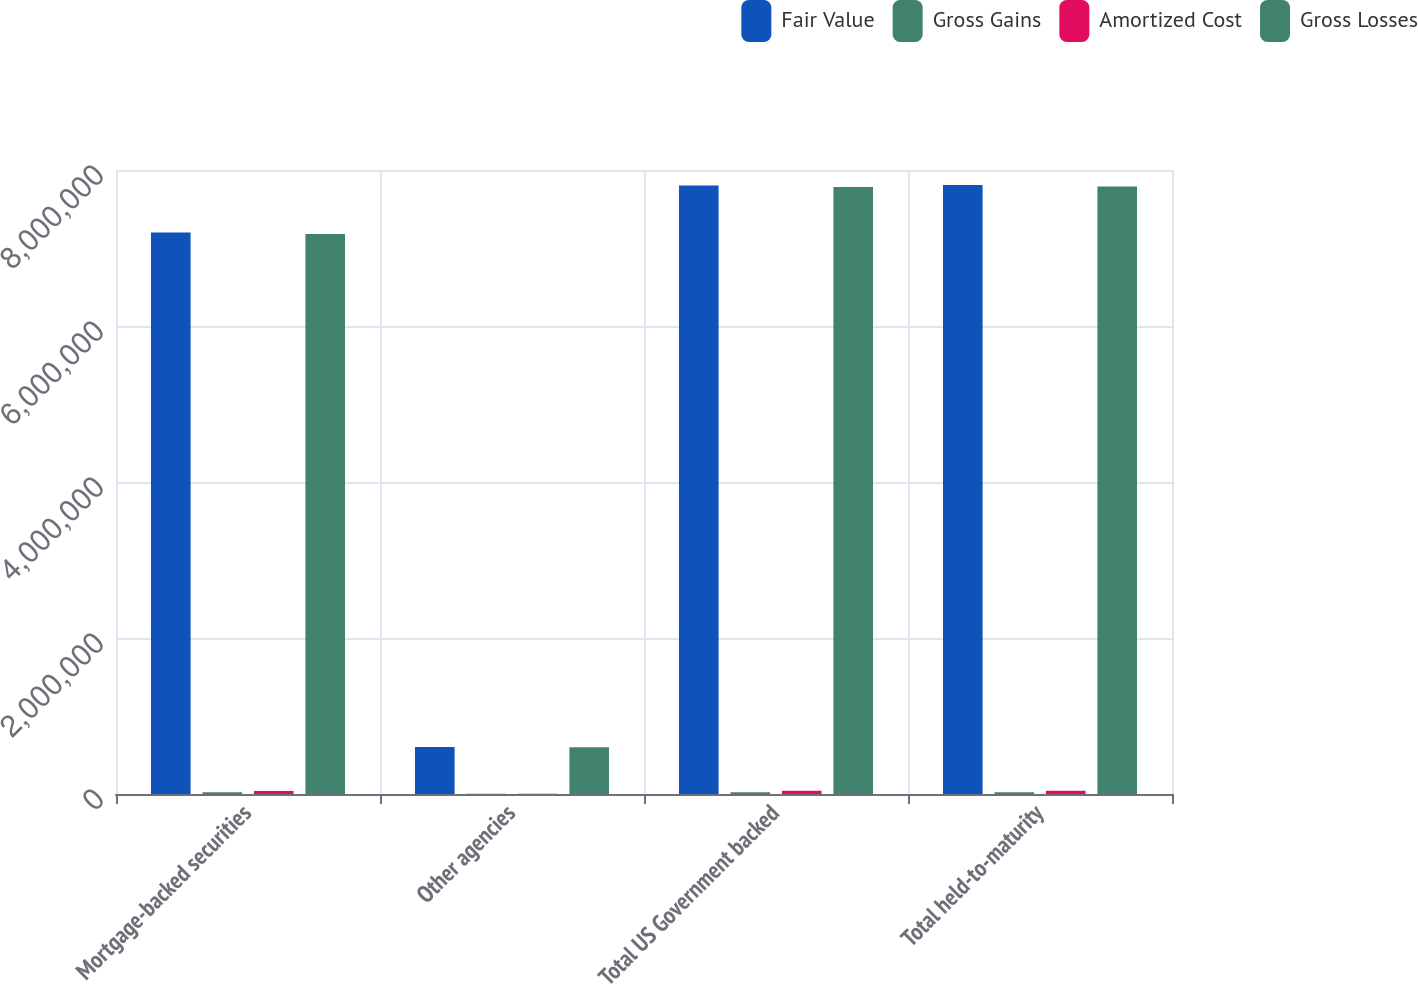Convert chart to OTSL. <chart><loc_0><loc_0><loc_500><loc_500><stacked_bar_chart><ecel><fcel>Mortgage-backed securities<fcel>Other agencies<fcel>Total US Government backed<fcel>Total held-to-maturity<nl><fcel>Fair Value<fcel>7.19834e+06<fcel>602424<fcel>7.80077e+06<fcel>7.80694e+06<nl><fcel>Gross Gains<fcel>20883<fcel>1690<fcel>22573<fcel>22573<nl><fcel>Amortized Cost<fcel>38493<fcel>3482<fcel>41975<fcel>42244<nl><fcel>Gross Losses<fcel>7.18073e+06<fcel>600632<fcel>7.78137e+06<fcel>7.78727e+06<nl></chart> 